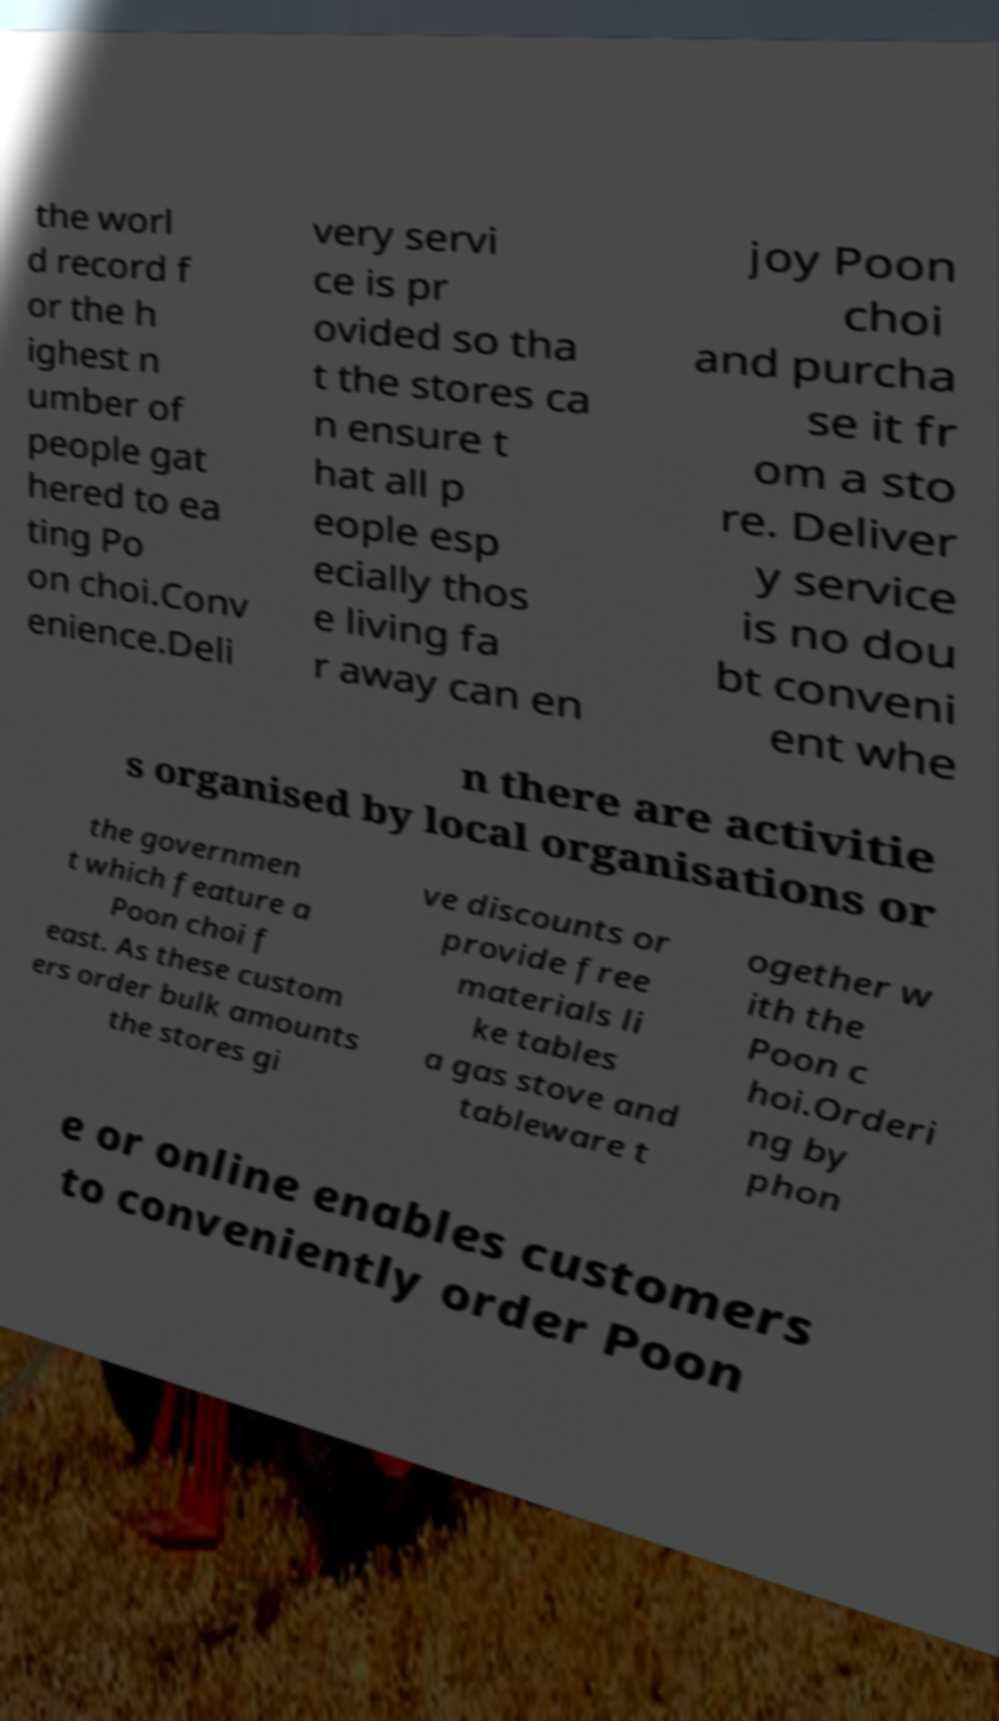I need the written content from this picture converted into text. Can you do that? the worl d record f or the h ighest n umber of people gat hered to ea ting Po on choi.Conv enience.Deli very servi ce is pr ovided so tha t the stores ca n ensure t hat all p eople esp ecially thos e living fa r away can en joy Poon choi and purcha se it fr om a sto re. Deliver y service is no dou bt conveni ent whe n there are activitie s organised by local organisations or the governmen t which feature a Poon choi f east. As these custom ers order bulk amounts the stores gi ve discounts or provide free materials li ke tables a gas stove and tableware t ogether w ith the Poon c hoi.Orderi ng by phon e or online enables customers to conveniently order Poon 